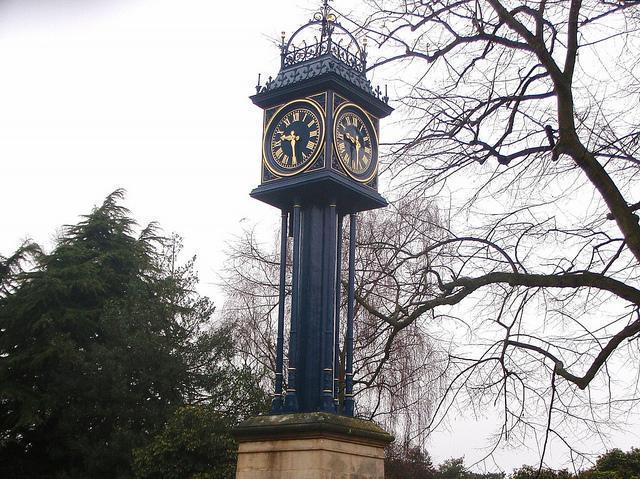How many clocks can you see?
Give a very brief answer. 2. How many zebras are there?
Give a very brief answer. 0. 